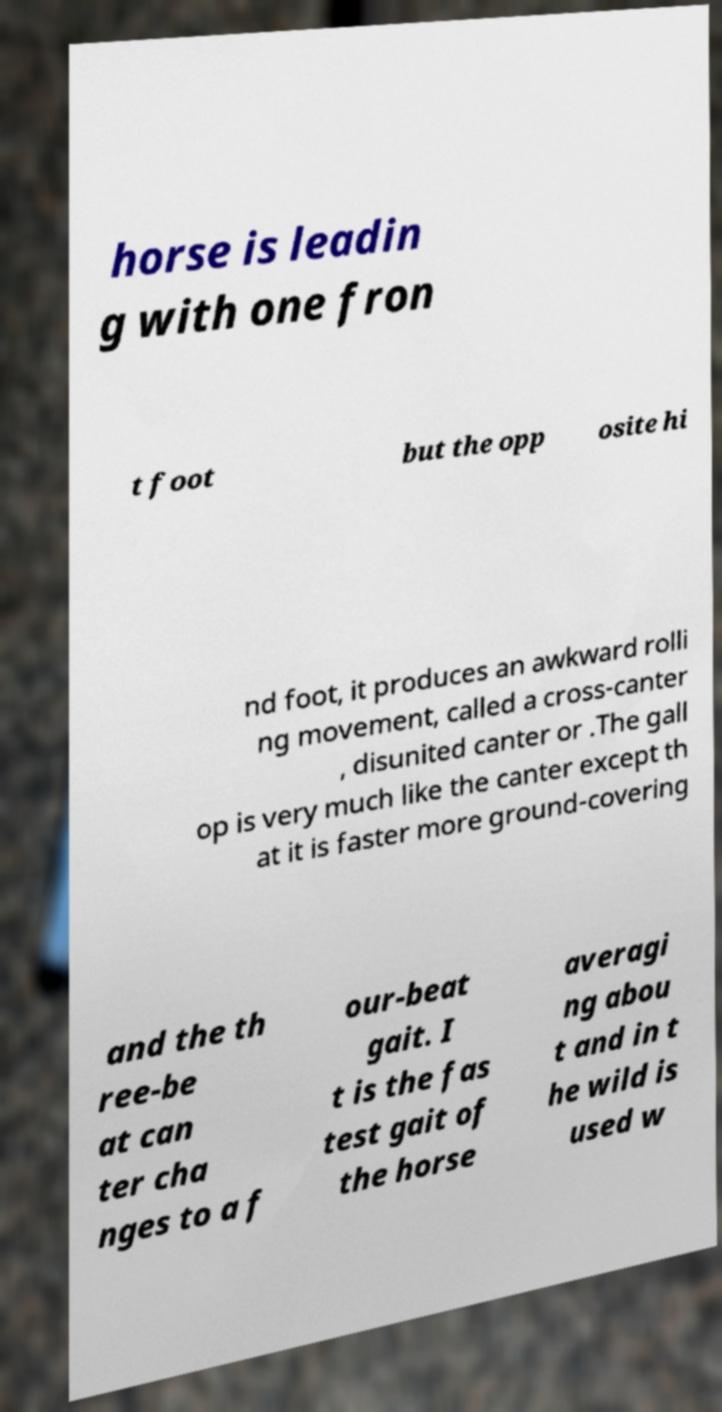Can you accurately transcribe the text from the provided image for me? horse is leadin g with one fron t foot but the opp osite hi nd foot, it produces an awkward rolli ng movement, called a cross-canter , disunited canter or .The gall op is very much like the canter except th at it is faster more ground-covering and the th ree-be at can ter cha nges to a f our-beat gait. I t is the fas test gait of the horse averagi ng abou t and in t he wild is used w 